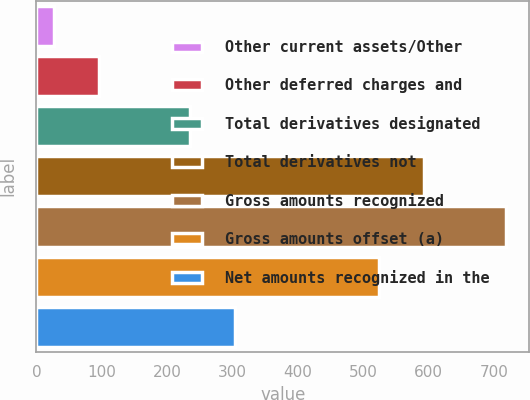Convert chart. <chart><loc_0><loc_0><loc_500><loc_500><bar_chart><fcel>Other current assets/Other<fcel>Other deferred charges and<fcel>Total derivatives designated<fcel>Total derivatives not<fcel>Gross amounts recognized<fcel>Gross amounts offset (a)<fcel>Net amounts recognized in the<nl><fcel>27<fcel>96.1<fcel>234.3<fcel>593.1<fcel>718<fcel>524<fcel>303.4<nl></chart> 